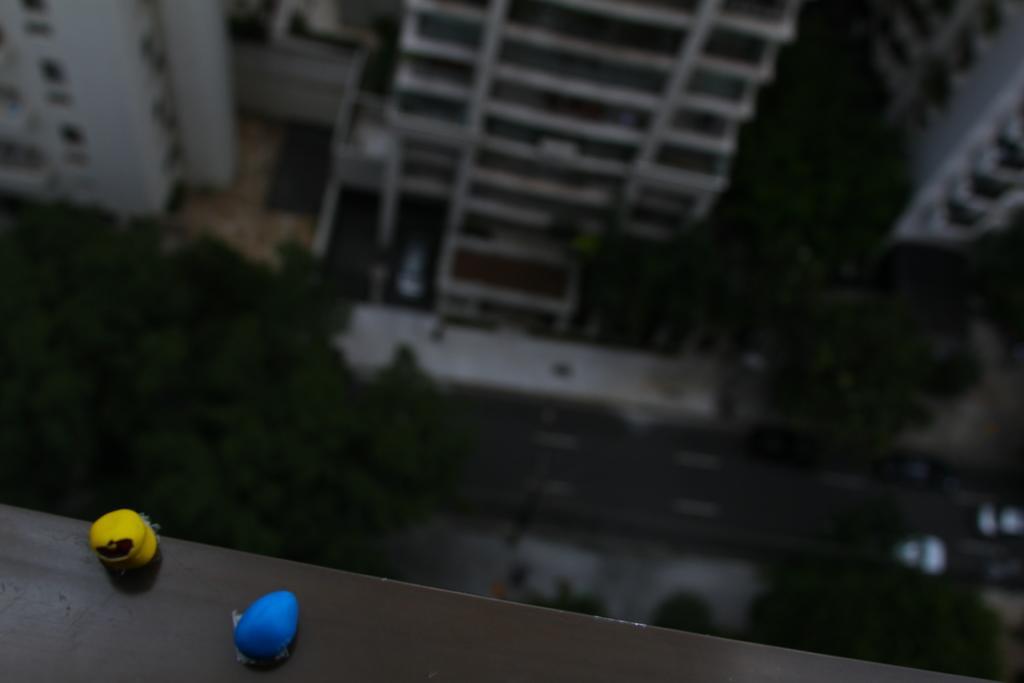Could you give a brief overview of what you see in this image? In the picture I can see two objects on the black color surface. These two objects are yellow and blue in color. In the background I can see buildings and some other objects. The background of the image is blurred. 